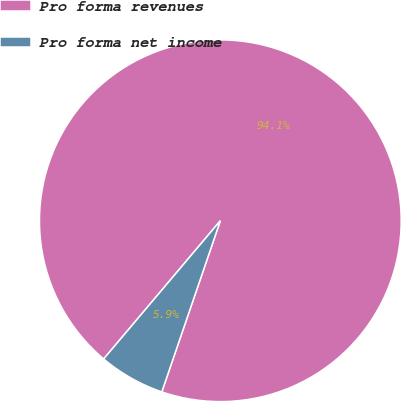Convert chart. <chart><loc_0><loc_0><loc_500><loc_500><pie_chart><fcel>Pro forma revenues<fcel>Pro forma net income<nl><fcel>94.09%<fcel>5.91%<nl></chart> 